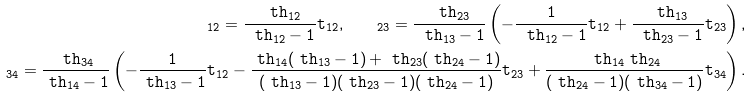Convert formula to latex. <formula><loc_0><loc_0><loc_500><loc_500>\tt _ { 1 2 } = \frac { \ t h _ { 1 2 } } { \ t h _ { 1 2 } - 1 } t _ { 1 2 } , \quad \tt _ { 2 3 } = \frac { \ t h _ { 2 3 } } { \ t h _ { 1 3 } - 1 } \left ( - \frac { 1 } { \ t h _ { 1 2 } - 1 } t _ { 1 2 } + \frac { \ t h _ { 1 3 } } { \ t h _ { 2 3 } - 1 } t _ { 2 3 } \right ) , \\ \tt _ { 3 4 } = \frac { \ t h _ { 3 4 } } { \ t h _ { 1 4 } - 1 } \left ( - \frac { 1 } { \ t h _ { 1 3 } - 1 } t _ { 1 2 } - \frac { \ t h _ { 1 4 } ( \ t h _ { 1 3 } - 1 ) + \ t h _ { 2 3 } ( \ t h _ { 2 4 } - 1 ) } { ( \ t h _ { 1 3 } - 1 ) ( \ t h _ { 2 3 } - 1 ) ( \ t h _ { 2 4 } - 1 ) } t _ { 2 3 } + \frac { \ t h _ { 1 4 } \ t h _ { 2 4 } } { ( \ t h _ { 2 4 } - 1 ) ( \ t h _ { 3 4 } - 1 ) } t _ { 3 4 } \right ) .</formula> 